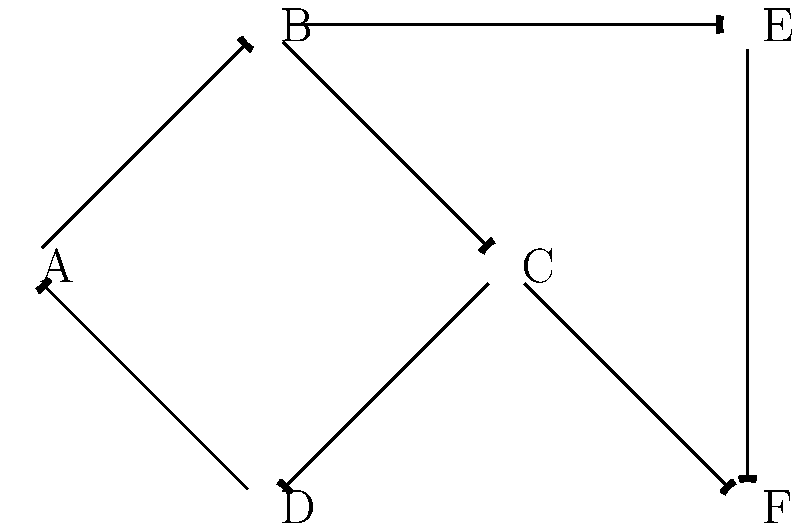In the network diagram representing climate feedback loops, what is the minimum number of edges that need to be removed to disconnect node A from node C, assuming all edges are directional? To solve this problem, we need to analyze the paths from node A to node C:

1. First, identify all paths from A to C:
   Path 1: A → B → C
   Path 2: A → D → B → C
   Path 3: A → D → A → B → C (cycles back to A)

2. To disconnect A from C, we need to break all these paths.

3. Removing the edge B → C would break all paths simultaneously, as it's the common final step in all routes from A to C.

4. Alternatively, removing A → B and A → D would also disconnect A from C, but this requires removing two edges instead of one.

5. Since we're asked for the minimum number of edges to remove, the answer is 1.

6. It's important to note that because the edges are directional, removing C → D does not affect the paths from A to C.

Therefore, the minimum number of edges that need to be removed to disconnect node A from node C is 1.
Answer: 1 